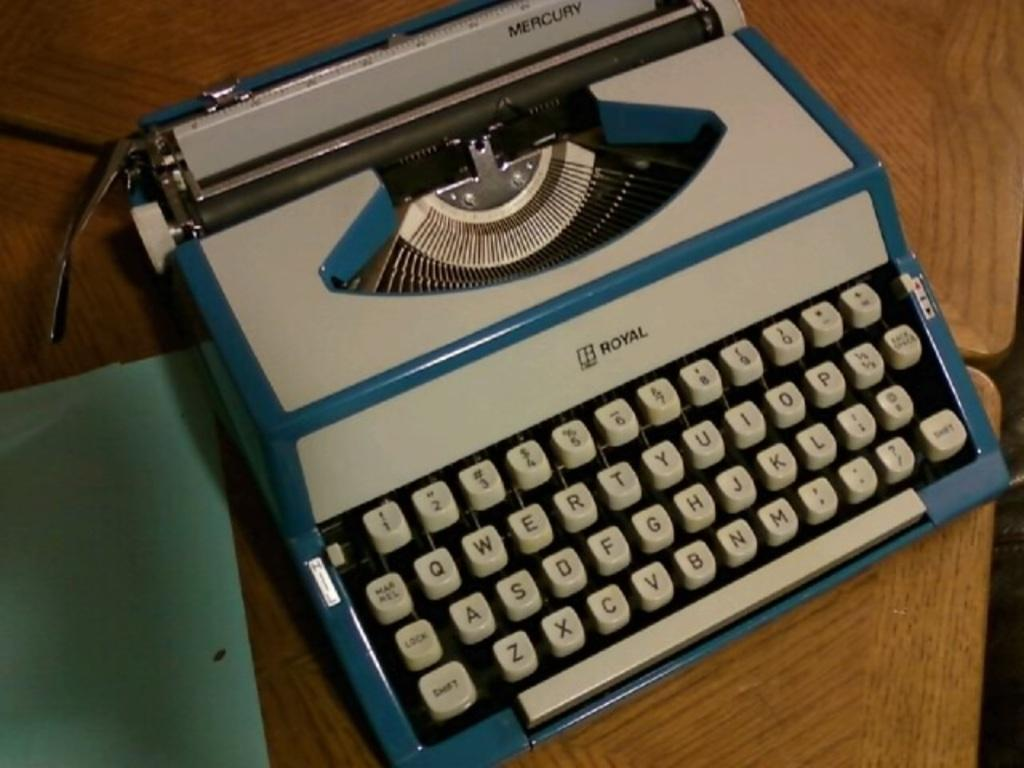<image>
Write a terse but informative summary of the picture. A blue and tan Royal typewriter sitting on a wooden desk. 